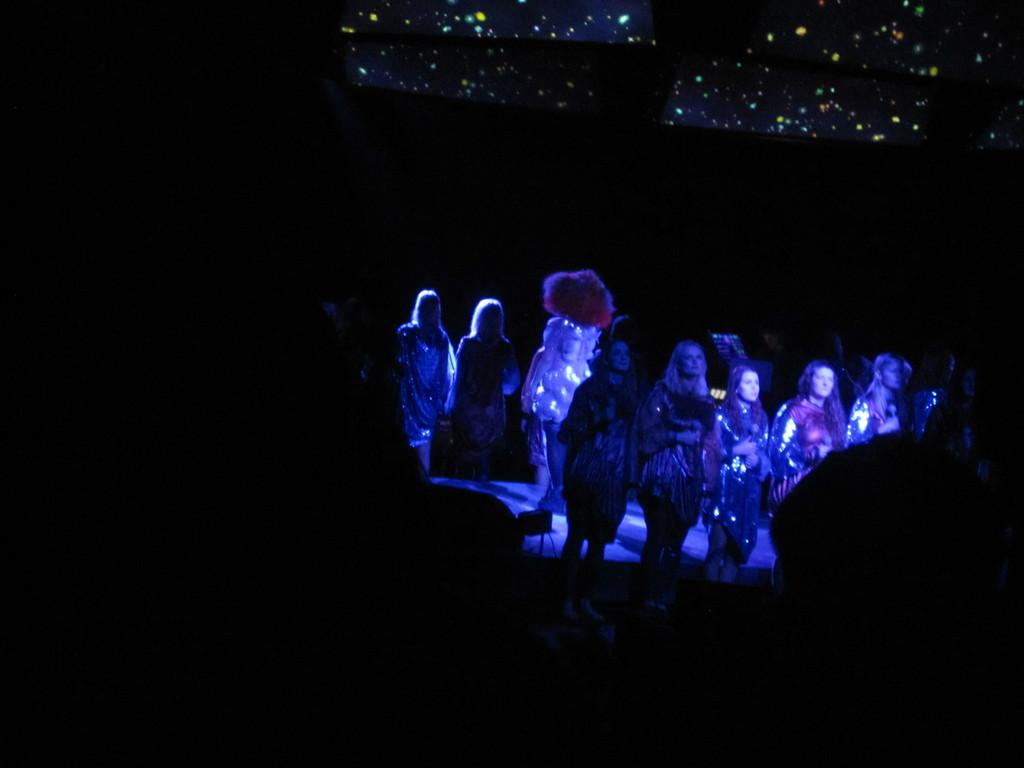What is happening in the image? There is a group of people standing in the image. What else can be seen in the image besides the people? There are objects present in the image. Can you describe the background of the image? The background of the image is dark. What type of boundary can be seen in the image? There is no boundary present in the image; it features a group of people and objects against a dark background. What cord is connected to the objects in the image? There is no cord connected to the objects in the image; the objects are not specified in the provided facts. 